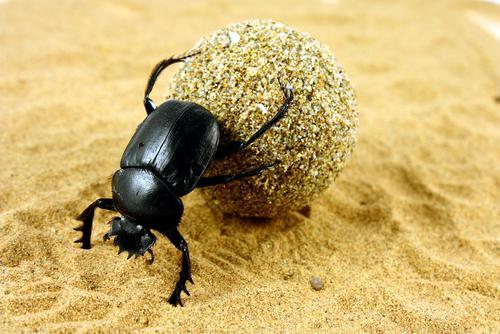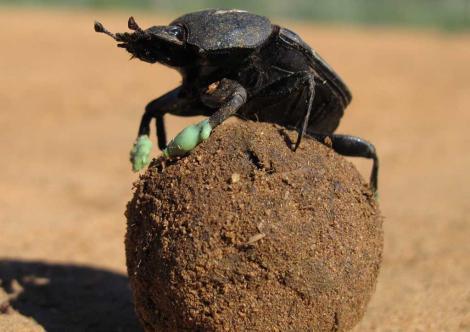The first image is the image on the left, the second image is the image on the right. Examine the images to the left and right. Is the description "The beetle in the image on the left is sitting on top the clod of dirt." accurate? Answer yes or no. No. 